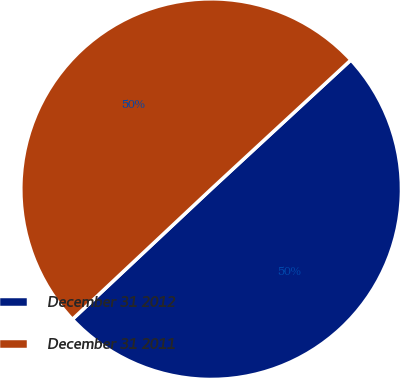<chart> <loc_0><loc_0><loc_500><loc_500><pie_chart><fcel>December 31 2012<fcel>December 31 2011<nl><fcel>49.88%<fcel>50.12%<nl></chart> 